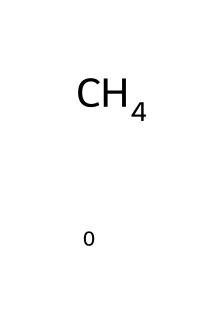How many hydrogen atoms are present in methane? The SMILES representation shows one carbon atom (C) bonded to four hydrogen atoms (H). Therefore, methane contains four hydrogen atoms.
Answer: four What type of bond connects the carbon and hydrogen atoms in methane? The structure indicates that each hydrogen is connected to the carbon atom by a single bond, which classifies them as covalent bonds.
Answer: covalent What is the molecular formula of methane? The chemical composition indicates one carbon atom and four hydrogen atoms, leading to the molecular formula CH4.
Answer: CH4 Is methane a greenhouse gas? Methane is known as a greenhouse gas due to its ability to trap heat in the atmosphere, significantly contributing to global warming.
Answer: yes What is the significance of methane's molecular structure in terms of its stability? The tetrahedral arrangement of one carbon atom bonded to four hydrogen atoms contributes to methane's stability, as it minimizes steric hindrance and allows for strong covalent bonds.
Answer: stability How many total atoms are present in a molecule of methane? By counting the one carbon atom and four hydrogen atoms, we find there are a total of five atoms in a methane molecule.
Answer: five 